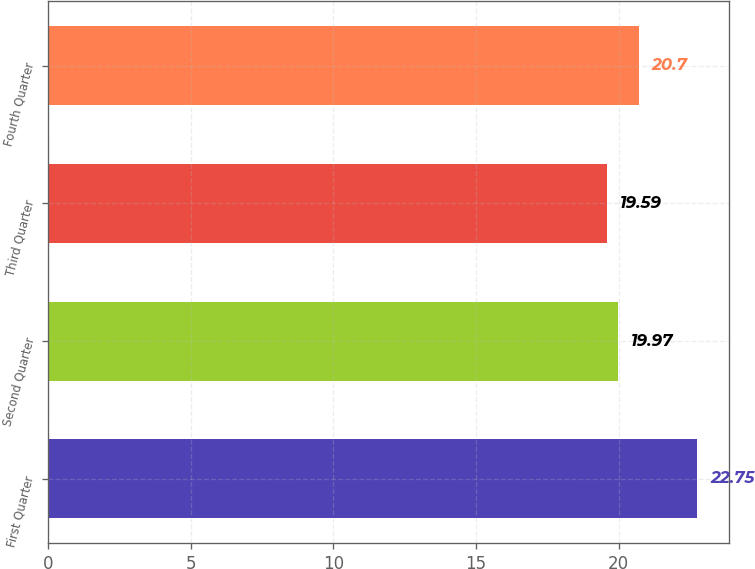<chart> <loc_0><loc_0><loc_500><loc_500><bar_chart><fcel>First Quarter<fcel>Second Quarter<fcel>Third Quarter<fcel>Fourth Quarter<nl><fcel>22.75<fcel>19.97<fcel>19.59<fcel>20.7<nl></chart> 